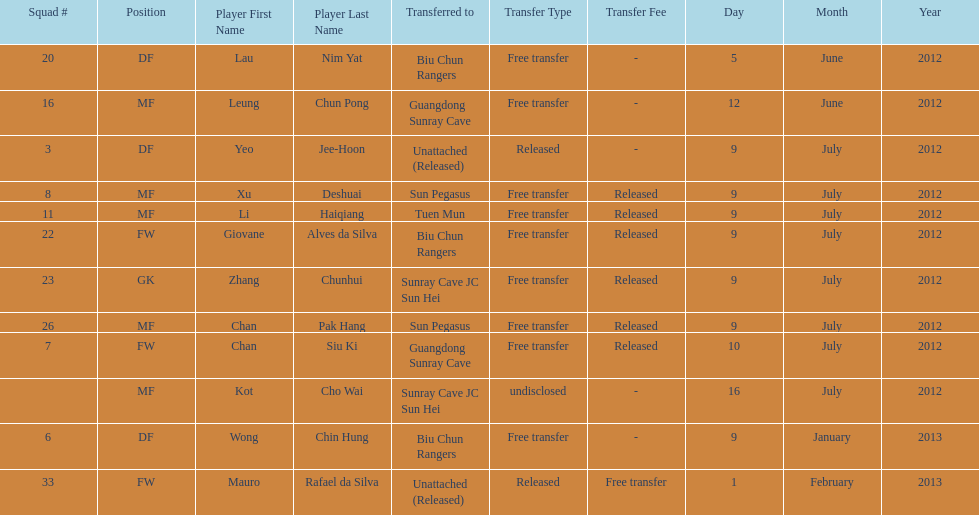How many consecutive players were released on july 9? 6. Can you give me this table as a dict? {'header': ['Squad #', 'Position', 'Player First Name', 'Player Last Name', 'Transferred to', 'Transfer Type', 'Transfer Fee', 'Day', 'Month', 'Year'], 'rows': [['20', 'DF', 'Lau', 'Nim Yat', 'Biu Chun Rangers', 'Free transfer', '-', '5', 'June', '2012'], ['16', 'MF', 'Leung', 'Chun Pong', 'Guangdong Sunray Cave', 'Free transfer', '-', '12', 'June', '2012'], ['3', 'DF', 'Yeo', 'Jee-Hoon', 'Unattached (Released)', 'Released', '-', '9', 'July', '2012'], ['8', 'MF', 'Xu', 'Deshuai', 'Sun Pegasus', 'Free transfer', 'Released', '9', 'July', '2012'], ['11', 'MF', 'Li', 'Haiqiang', 'Tuen Mun', 'Free transfer', 'Released', '9', 'July', '2012'], ['22', 'FW', 'Giovane', 'Alves da Silva', 'Biu Chun Rangers', 'Free transfer', 'Released', '9', 'July', '2012'], ['23', 'GK', 'Zhang', 'Chunhui', 'Sunray Cave JC Sun Hei', 'Free transfer', 'Released', '9', 'July', '2012'], ['26', 'MF', 'Chan', 'Pak Hang', 'Sun Pegasus', 'Free transfer', 'Released', '9', 'July', '2012'], ['7', 'FW', 'Chan', 'Siu Ki', 'Guangdong Sunray Cave', 'Free transfer', 'Released', '10', 'July', '2012'], ['', 'MF', 'Kot', 'Cho Wai', 'Sunray Cave JC Sun Hei', 'undisclosed', '-', '16', 'July', '2012'], ['6', 'DF', 'Wong', 'Chin Hung', 'Biu Chun Rangers', 'Free transfer', '-', '9', 'January', '2013'], ['33', 'FW', 'Mauro', 'Rafael da Silva', 'Unattached (Released)', 'Released', 'Free transfer', '1', 'February', '2013']]} 